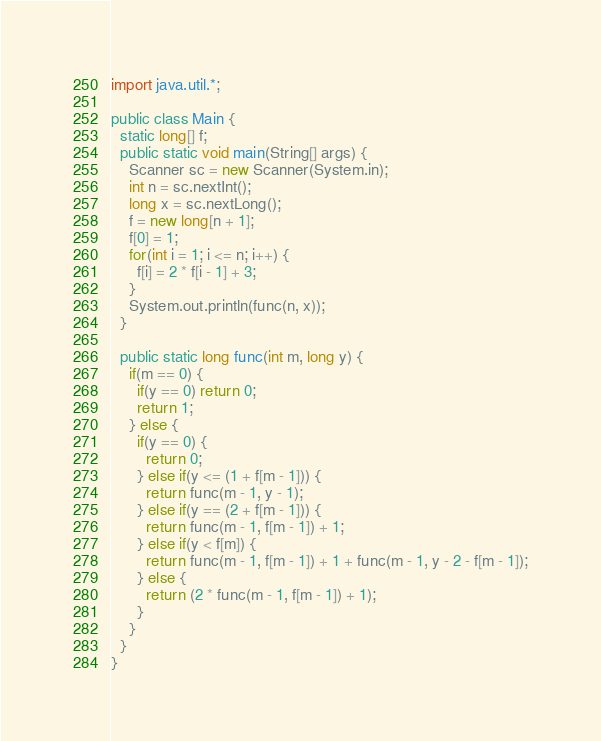Convert code to text. <code><loc_0><loc_0><loc_500><loc_500><_Java_>import java.util.*;

public class Main {
  static long[] f;
  public static void main(String[] args) {
    Scanner sc = new Scanner(System.in);
    int n = sc.nextInt();
    long x = sc.nextLong();
    f = new long[n + 1];
    f[0] = 1;
    for(int i = 1; i <= n; i++) {
      f[i] = 2 * f[i - 1] + 3;
    }
    System.out.println(func(n, x));
  }

  public static long func(int m, long y) {
    if(m == 0) {
      if(y == 0) return 0;
      return 1;
    } else {
      if(y == 0) {
        return 0;
      } else if(y <= (1 + f[m - 1])) {
        return func(m - 1, y - 1);
      } else if(y == (2 + f[m - 1])) {
        return func(m - 1, f[m - 1]) + 1;
      } else if(y < f[m]) {
        return func(m - 1, f[m - 1]) + 1 + func(m - 1, y - 2 - f[m - 1]);
      } else {
        return (2 * func(m - 1, f[m - 1]) + 1); 
      }      
    }
  }
}</code> 